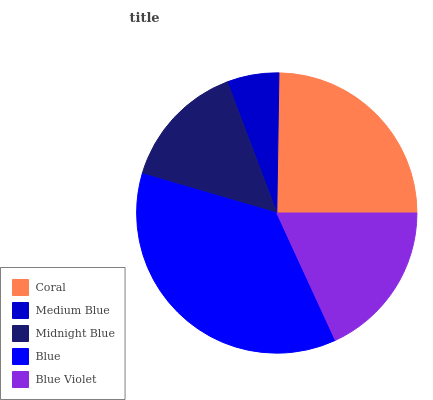Is Medium Blue the minimum?
Answer yes or no. Yes. Is Blue the maximum?
Answer yes or no. Yes. Is Midnight Blue the minimum?
Answer yes or no. No. Is Midnight Blue the maximum?
Answer yes or no. No. Is Midnight Blue greater than Medium Blue?
Answer yes or no. Yes. Is Medium Blue less than Midnight Blue?
Answer yes or no. Yes. Is Medium Blue greater than Midnight Blue?
Answer yes or no. No. Is Midnight Blue less than Medium Blue?
Answer yes or no. No. Is Blue Violet the high median?
Answer yes or no. Yes. Is Blue Violet the low median?
Answer yes or no. Yes. Is Coral the high median?
Answer yes or no. No. Is Medium Blue the low median?
Answer yes or no. No. 